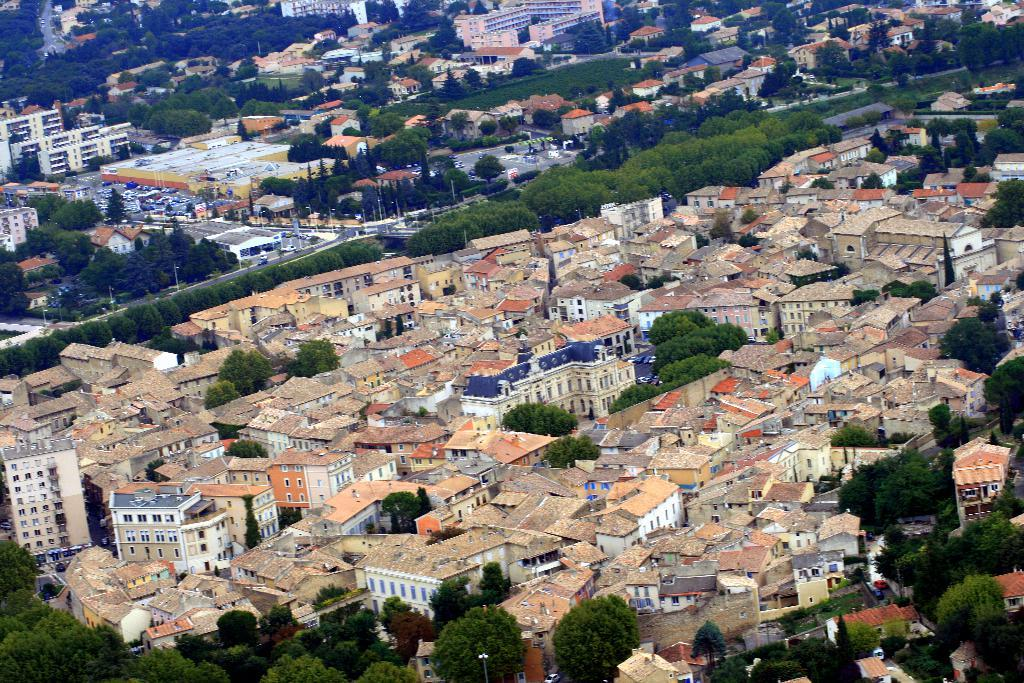What type of structures can be seen in the image? There are houses and buildings in the image. What natural elements are present in the image? There are trees in the image. What man-made objects can be seen in the image? There are poles in the image. What type of quill is being used to write on the trees in the image? There are no quills or writing on the trees in the image; it features houses, buildings, trees, and poles. 